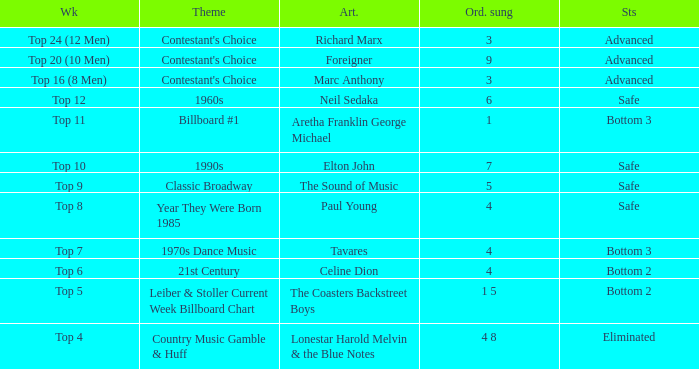What is the status when the artist is Neil Sedaka? Safe. 